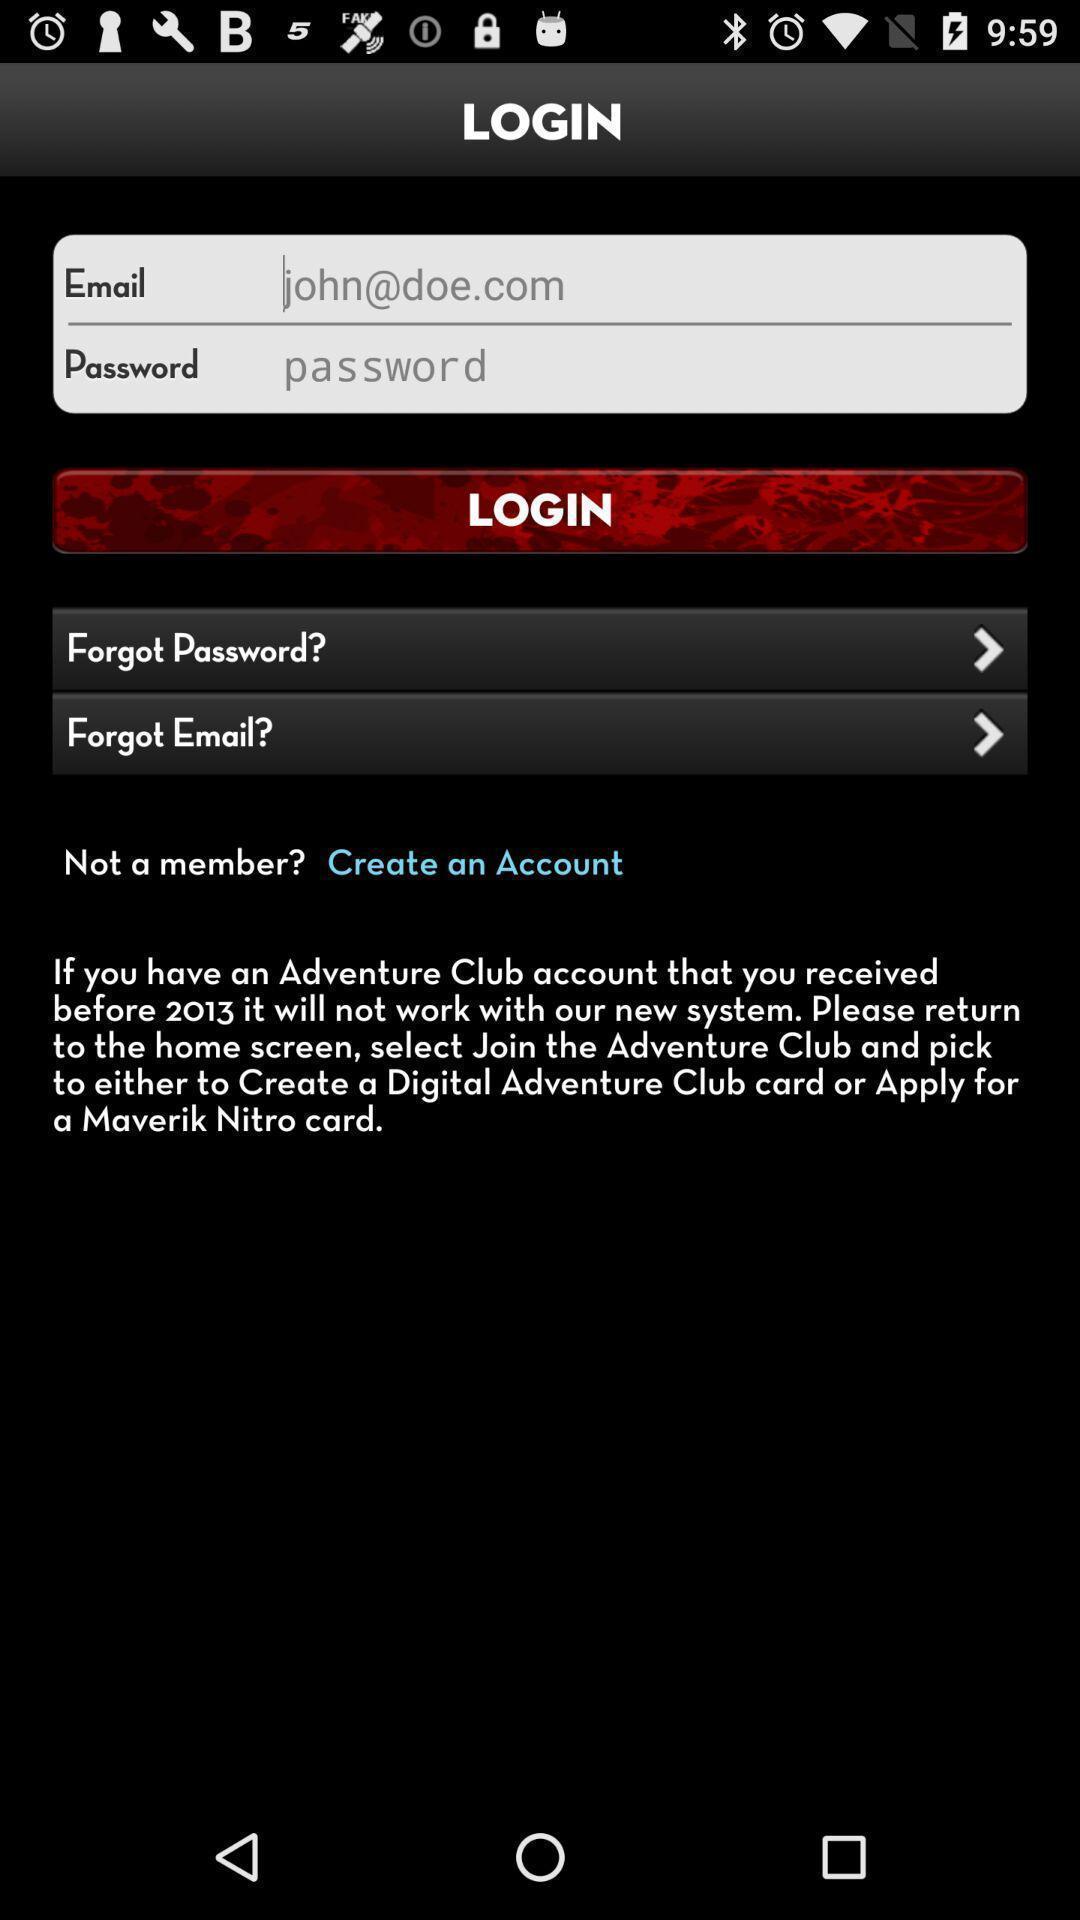Summarize the information in this screenshot. Screen displaying the login page. 